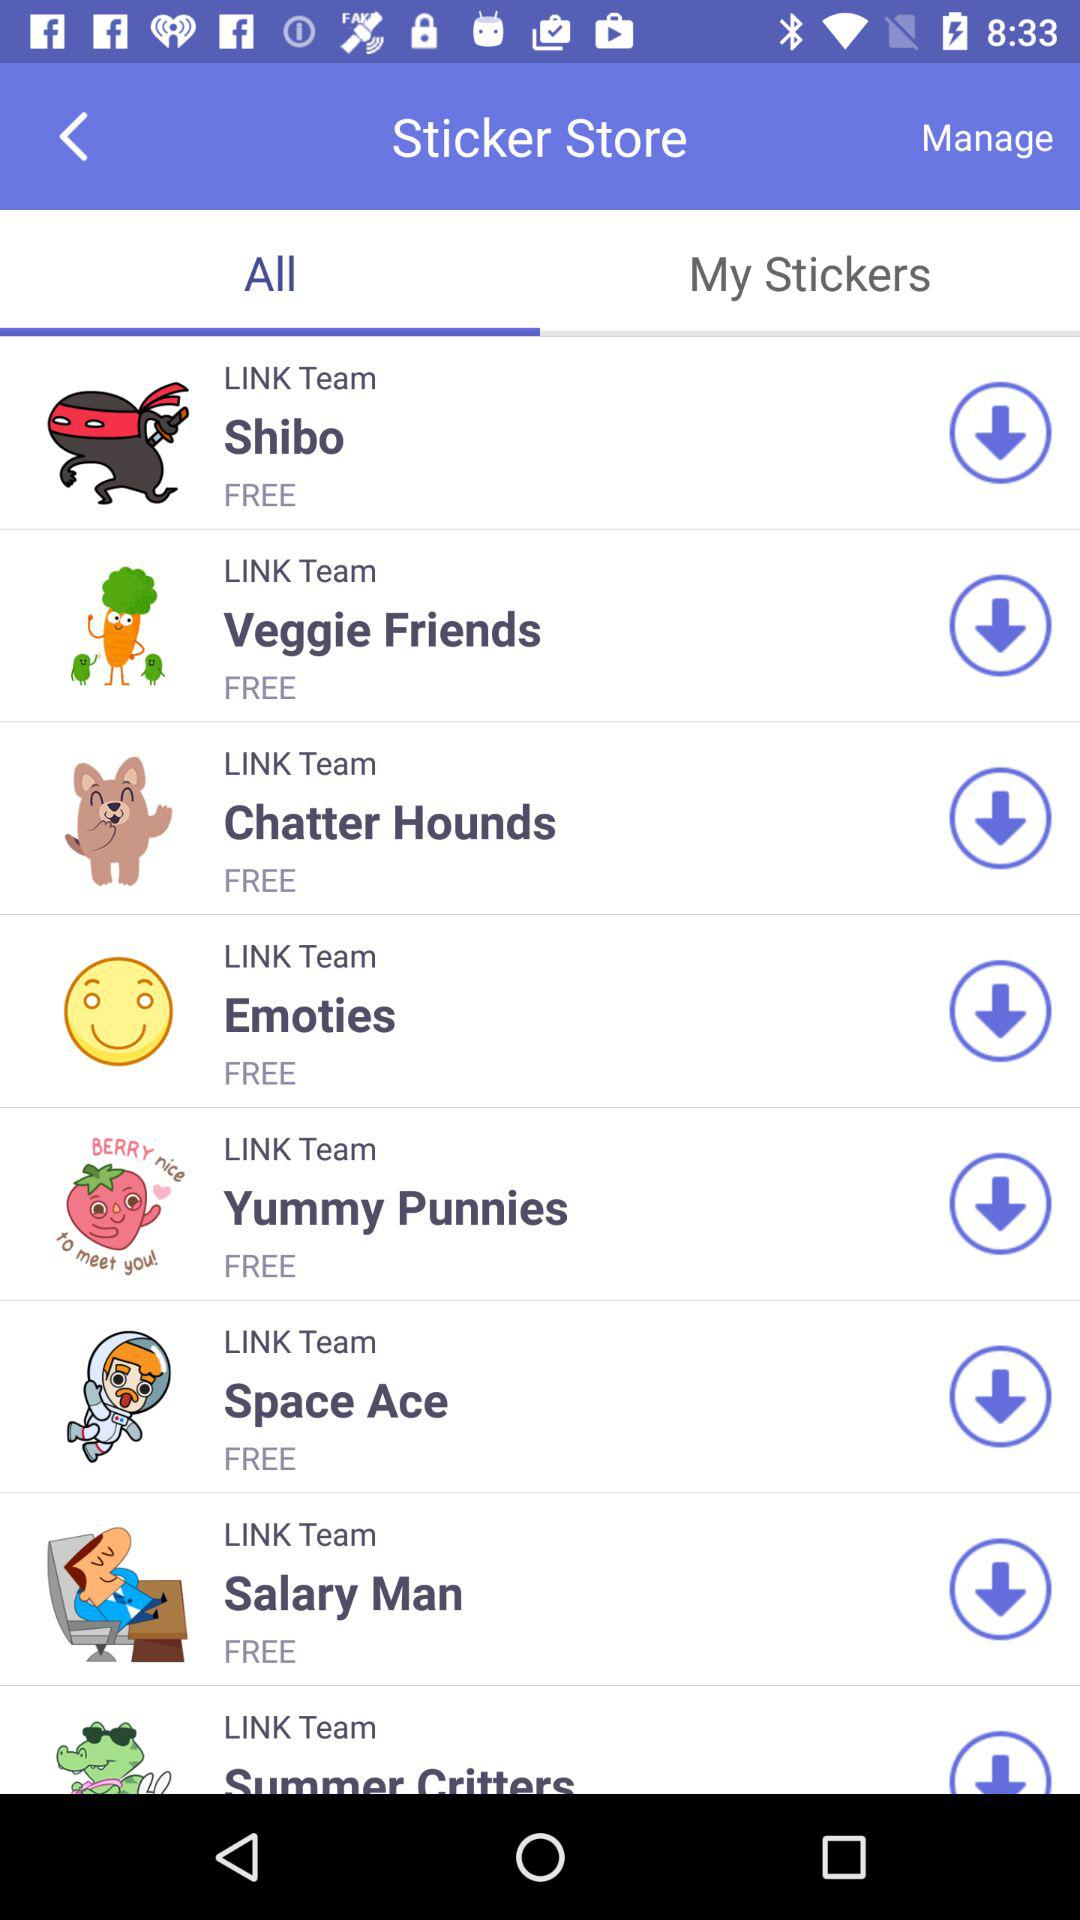Which tab am I on? You are on "All" tab. 